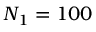<formula> <loc_0><loc_0><loc_500><loc_500>N _ { 1 } = 1 0 0</formula> 